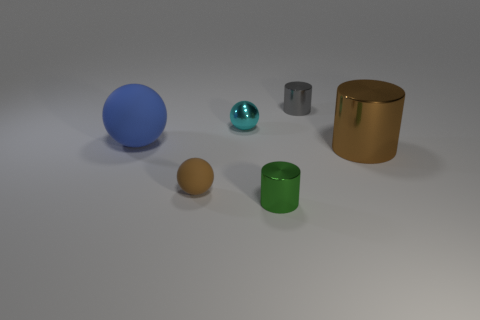Add 1 small cyan metallic objects. How many objects exist? 7 Subtract all tiny blue metal cylinders. Subtract all green cylinders. How many objects are left? 5 Add 4 small gray shiny cylinders. How many small gray shiny cylinders are left? 5 Add 5 large gray rubber cylinders. How many large gray rubber cylinders exist? 5 Subtract 0 yellow balls. How many objects are left? 6 